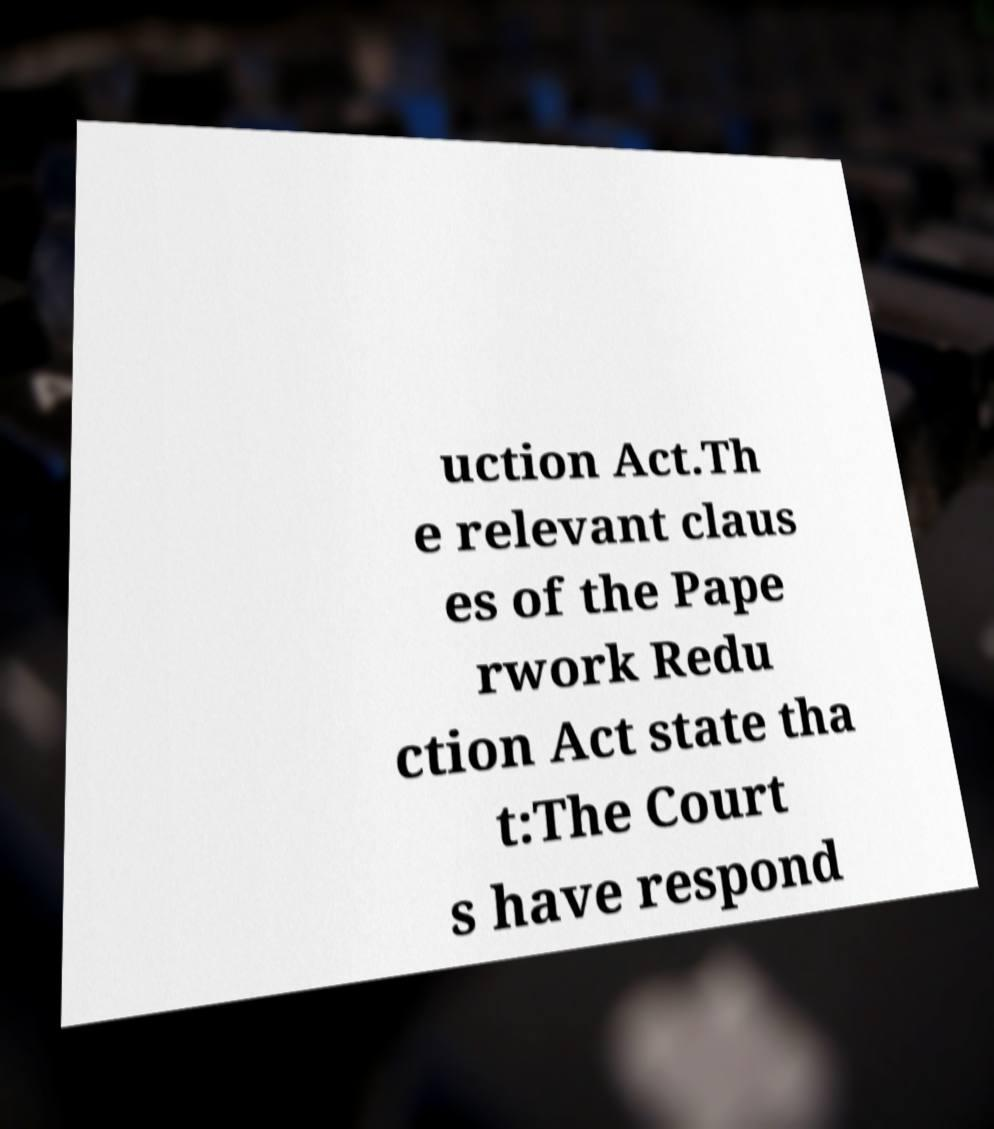There's text embedded in this image that I need extracted. Can you transcribe it verbatim? uction Act.Th e relevant claus es of the Pape rwork Redu ction Act state tha t:The Court s have respond 